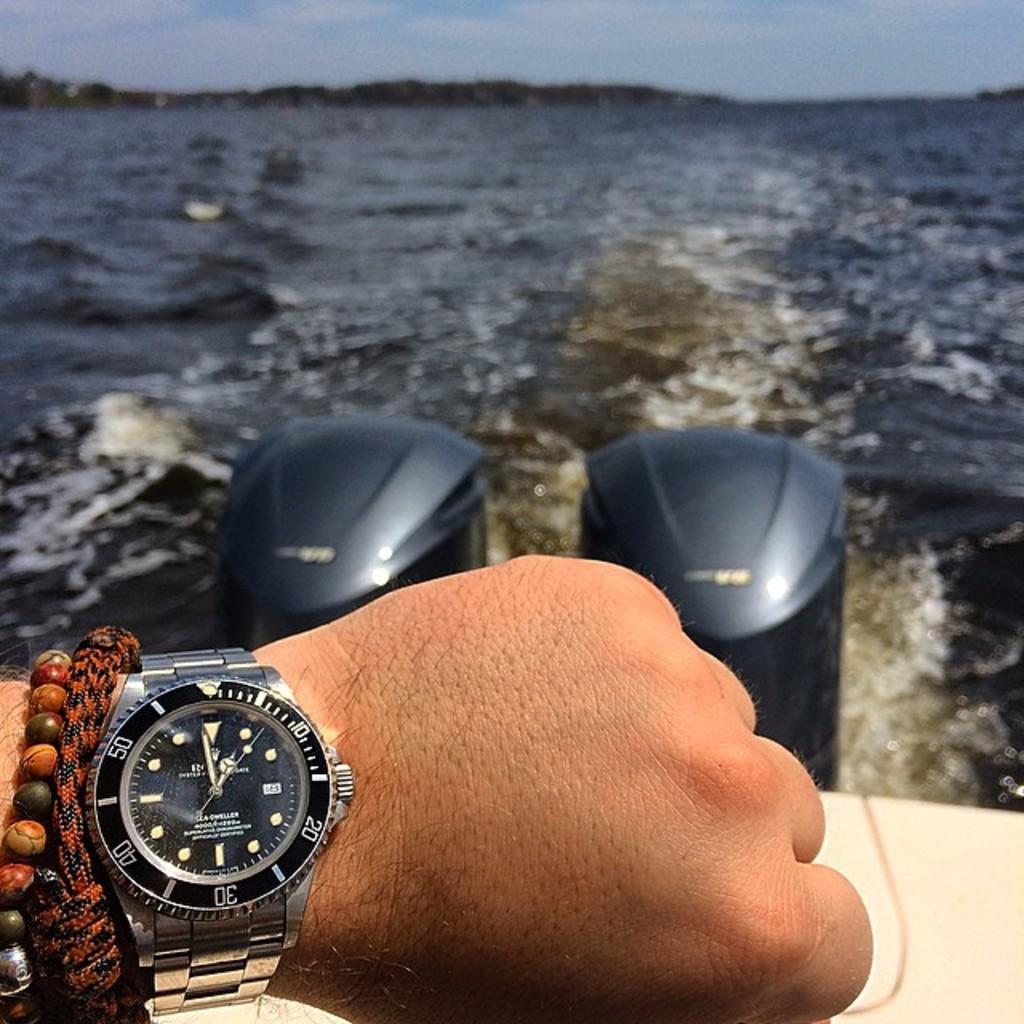<image>
Present a compact description of the photo's key features. A hand wearing a Sea Dweller watch that shows the time as 12:59 in front of boat engines. 